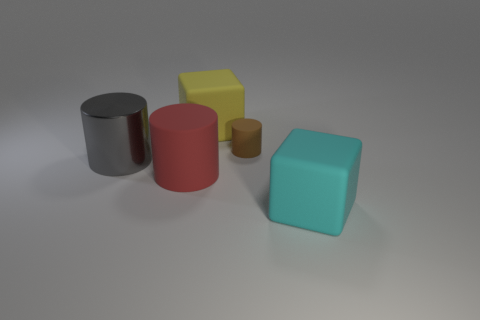Add 1 big gray metallic things. How many objects exist? 6 Subtract all blocks. How many objects are left? 3 Subtract all small brown matte objects. Subtract all gray cylinders. How many objects are left? 3 Add 4 red matte cylinders. How many red matte cylinders are left? 5 Add 2 small cyan metal spheres. How many small cyan metal spheres exist? 2 Subtract 0 gray spheres. How many objects are left? 5 